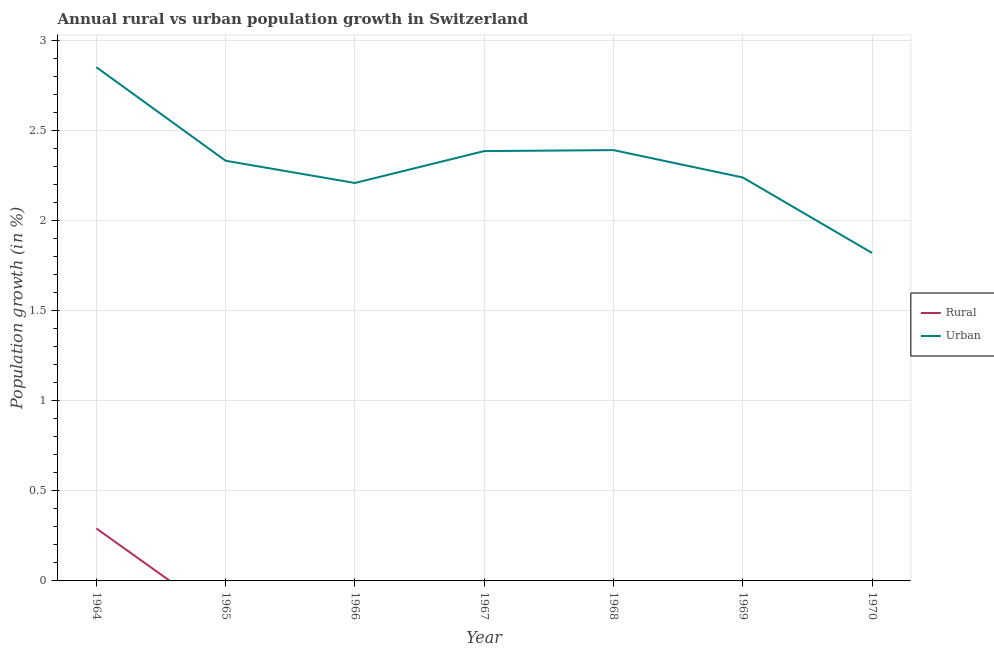How many different coloured lines are there?
Provide a short and direct response. 2. Is the number of lines equal to the number of legend labels?
Your response must be concise. No. What is the rural population growth in 1969?
Offer a terse response. 0. Across all years, what is the maximum urban population growth?
Offer a very short reply. 2.85. Across all years, what is the minimum rural population growth?
Offer a terse response. 0. In which year was the rural population growth maximum?
Provide a short and direct response. 1964. What is the total rural population growth in the graph?
Offer a terse response. 0.29. What is the difference between the urban population growth in 1964 and that in 1968?
Provide a succinct answer. 0.46. What is the difference between the urban population growth in 1966 and the rural population growth in 1967?
Ensure brevity in your answer.  2.21. What is the average urban population growth per year?
Give a very brief answer. 2.32. In the year 1964, what is the difference between the urban population growth and rural population growth?
Your response must be concise. 2.56. In how many years, is the rural population growth greater than 0.7 %?
Keep it short and to the point. 0. What is the ratio of the urban population growth in 1964 to that in 1966?
Give a very brief answer. 1.29. Is the urban population growth in 1968 less than that in 1969?
Give a very brief answer. No. What is the difference between the highest and the second highest urban population growth?
Your answer should be compact. 0.46. What is the difference between the highest and the lowest urban population growth?
Give a very brief answer. 1.03. Is the sum of the urban population growth in 1967 and 1969 greater than the maximum rural population growth across all years?
Ensure brevity in your answer.  Yes. How many lines are there?
Offer a very short reply. 2. How many years are there in the graph?
Offer a very short reply. 7. What is the difference between two consecutive major ticks on the Y-axis?
Make the answer very short. 0.5. Are the values on the major ticks of Y-axis written in scientific E-notation?
Make the answer very short. No. Does the graph contain any zero values?
Your answer should be compact. Yes. Where does the legend appear in the graph?
Provide a succinct answer. Center right. How are the legend labels stacked?
Keep it short and to the point. Vertical. What is the title of the graph?
Ensure brevity in your answer.  Annual rural vs urban population growth in Switzerland. Does "Technicians" appear as one of the legend labels in the graph?
Ensure brevity in your answer.  No. What is the label or title of the Y-axis?
Your response must be concise. Population growth (in %). What is the Population growth (in %) in Rural in 1964?
Give a very brief answer. 0.29. What is the Population growth (in %) in Urban  in 1964?
Make the answer very short. 2.85. What is the Population growth (in %) in Rural in 1965?
Offer a terse response. 0. What is the Population growth (in %) in Urban  in 1965?
Ensure brevity in your answer.  2.33. What is the Population growth (in %) of Rural in 1966?
Give a very brief answer. 0. What is the Population growth (in %) of Urban  in 1966?
Offer a terse response. 2.21. What is the Population growth (in %) in Urban  in 1967?
Your response must be concise. 2.38. What is the Population growth (in %) in Urban  in 1968?
Provide a short and direct response. 2.39. What is the Population growth (in %) of Urban  in 1969?
Provide a short and direct response. 2.24. What is the Population growth (in %) in Urban  in 1970?
Offer a terse response. 1.82. Across all years, what is the maximum Population growth (in %) of Rural?
Give a very brief answer. 0.29. Across all years, what is the maximum Population growth (in %) of Urban ?
Offer a terse response. 2.85. Across all years, what is the minimum Population growth (in %) of Urban ?
Provide a short and direct response. 1.82. What is the total Population growth (in %) of Rural in the graph?
Provide a succinct answer. 0.29. What is the total Population growth (in %) in Urban  in the graph?
Offer a very short reply. 16.22. What is the difference between the Population growth (in %) in Urban  in 1964 and that in 1965?
Keep it short and to the point. 0.52. What is the difference between the Population growth (in %) of Urban  in 1964 and that in 1966?
Make the answer very short. 0.64. What is the difference between the Population growth (in %) in Urban  in 1964 and that in 1967?
Offer a very short reply. 0.47. What is the difference between the Population growth (in %) in Urban  in 1964 and that in 1968?
Ensure brevity in your answer.  0.46. What is the difference between the Population growth (in %) in Urban  in 1964 and that in 1969?
Make the answer very short. 0.61. What is the difference between the Population growth (in %) of Urban  in 1964 and that in 1970?
Offer a terse response. 1.03. What is the difference between the Population growth (in %) of Urban  in 1965 and that in 1966?
Make the answer very short. 0.12. What is the difference between the Population growth (in %) in Urban  in 1965 and that in 1967?
Keep it short and to the point. -0.05. What is the difference between the Population growth (in %) in Urban  in 1965 and that in 1968?
Your response must be concise. -0.06. What is the difference between the Population growth (in %) of Urban  in 1965 and that in 1969?
Give a very brief answer. 0.09. What is the difference between the Population growth (in %) of Urban  in 1965 and that in 1970?
Your answer should be compact. 0.51. What is the difference between the Population growth (in %) of Urban  in 1966 and that in 1967?
Your answer should be compact. -0.18. What is the difference between the Population growth (in %) of Urban  in 1966 and that in 1968?
Give a very brief answer. -0.18. What is the difference between the Population growth (in %) of Urban  in 1966 and that in 1969?
Provide a short and direct response. -0.03. What is the difference between the Population growth (in %) of Urban  in 1966 and that in 1970?
Provide a short and direct response. 0.39. What is the difference between the Population growth (in %) of Urban  in 1967 and that in 1968?
Provide a short and direct response. -0.01. What is the difference between the Population growth (in %) of Urban  in 1967 and that in 1969?
Provide a succinct answer. 0.15. What is the difference between the Population growth (in %) in Urban  in 1967 and that in 1970?
Your answer should be very brief. 0.57. What is the difference between the Population growth (in %) of Urban  in 1968 and that in 1969?
Your response must be concise. 0.15. What is the difference between the Population growth (in %) in Urban  in 1968 and that in 1970?
Offer a terse response. 0.57. What is the difference between the Population growth (in %) of Urban  in 1969 and that in 1970?
Offer a very short reply. 0.42. What is the difference between the Population growth (in %) of Rural in 1964 and the Population growth (in %) of Urban  in 1965?
Ensure brevity in your answer.  -2.04. What is the difference between the Population growth (in %) in Rural in 1964 and the Population growth (in %) in Urban  in 1966?
Offer a very short reply. -1.92. What is the difference between the Population growth (in %) of Rural in 1964 and the Population growth (in %) of Urban  in 1967?
Make the answer very short. -2.09. What is the difference between the Population growth (in %) of Rural in 1964 and the Population growth (in %) of Urban  in 1968?
Give a very brief answer. -2.1. What is the difference between the Population growth (in %) of Rural in 1964 and the Population growth (in %) of Urban  in 1969?
Give a very brief answer. -1.95. What is the difference between the Population growth (in %) in Rural in 1964 and the Population growth (in %) in Urban  in 1970?
Provide a succinct answer. -1.53. What is the average Population growth (in %) of Rural per year?
Ensure brevity in your answer.  0.04. What is the average Population growth (in %) in Urban  per year?
Offer a terse response. 2.32. In the year 1964, what is the difference between the Population growth (in %) in Rural and Population growth (in %) in Urban ?
Your answer should be compact. -2.56. What is the ratio of the Population growth (in %) in Urban  in 1964 to that in 1965?
Your answer should be compact. 1.22. What is the ratio of the Population growth (in %) in Urban  in 1964 to that in 1966?
Keep it short and to the point. 1.29. What is the ratio of the Population growth (in %) in Urban  in 1964 to that in 1967?
Offer a terse response. 1.2. What is the ratio of the Population growth (in %) of Urban  in 1964 to that in 1968?
Your answer should be compact. 1.19. What is the ratio of the Population growth (in %) in Urban  in 1964 to that in 1969?
Offer a very short reply. 1.27. What is the ratio of the Population growth (in %) of Urban  in 1964 to that in 1970?
Ensure brevity in your answer.  1.57. What is the ratio of the Population growth (in %) of Urban  in 1965 to that in 1966?
Provide a short and direct response. 1.06. What is the ratio of the Population growth (in %) in Urban  in 1965 to that in 1967?
Provide a short and direct response. 0.98. What is the ratio of the Population growth (in %) in Urban  in 1965 to that in 1968?
Your answer should be very brief. 0.98. What is the ratio of the Population growth (in %) in Urban  in 1965 to that in 1969?
Make the answer very short. 1.04. What is the ratio of the Population growth (in %) in Urban  in 1965 to that in 1970?
Your answer should be very brief. 1.28. What is the ratio of the Population growth (in %) in Urban  in 1966 to that in 1967?
Make the answer very short. 0.93. What is the ratio of the Population growth (in %) in Urban  in 1966 to that in 1968?
Make the answer very short. 0.92. What is the ratio of the Population growth (in %) of Urban  in 1966 to that in 1969?
Make the answer very short. 0.99. What is the ratio of the Population growth (in %) in Urban  in 1966 to that in 1970?
Keep it short and to the point. 1.21. What is the ratio of the Population growth (in %) in Urban  in 1967 to that in 1969?
Provide a succinct answer. 1.07. What is the ratio of the Population growth (in %) of Urban  in 1967 to that in 1970?
Your response must be concise. 1.31. What is the ratio of the Population growth (in %) in Urban  in 1968 to that in 1969?
Your answer should be very brief. 1.07. What is the ratio of the Population growth (in %) in Urban  in 1968 to that in 1970?
Your answer should be compact. 1.31. What is the ratio of the Population growth (in %) in Urban  in 1969 to that in 1970?
Offer a terse response. 1.23. What is the difference between the highest and the second highest Population growth (in %) of Urban ?
Provide a succinct answer. 0.46. What is the difference between the highest and the lowest Population growth (in %) in Rural?
Your response must be concise. 0.29. What is the difference between the highest and the lowest Population growth (in %) in Urban ?
Provide a succinct answer. 1.03. 